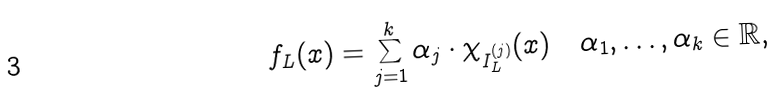Convert formula to latex. <formula><loc_0><loc_0><loc_500><loc_500>f _ { L } ( x ) = \sum _ { j = 1 } ^ { k } \alpha _ { j } \cdot \chi _ { I _ { L } ^ { ( j ) } } ( x ) \quad \alpha _ { 1 } , \dots , \alpha _ { k } \in \mathbb { R } ,</formula> 